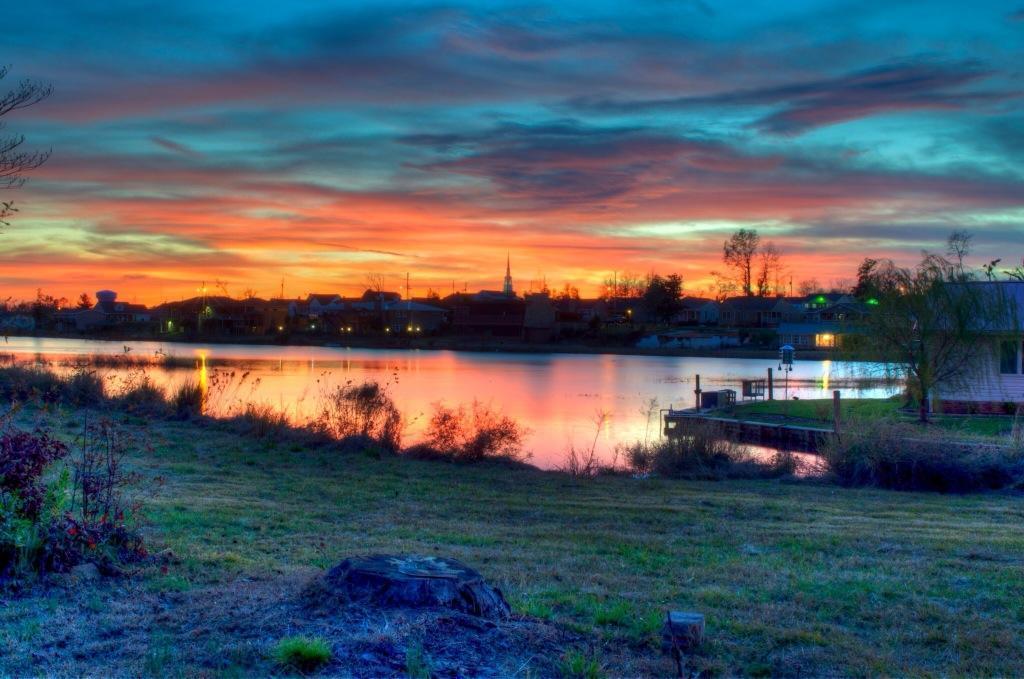In one or two sentences, can you explain what this image depicts? In this image we can see a lake, there are some buildings, trees, poles, plants and grass, in the background we can see the sky. 